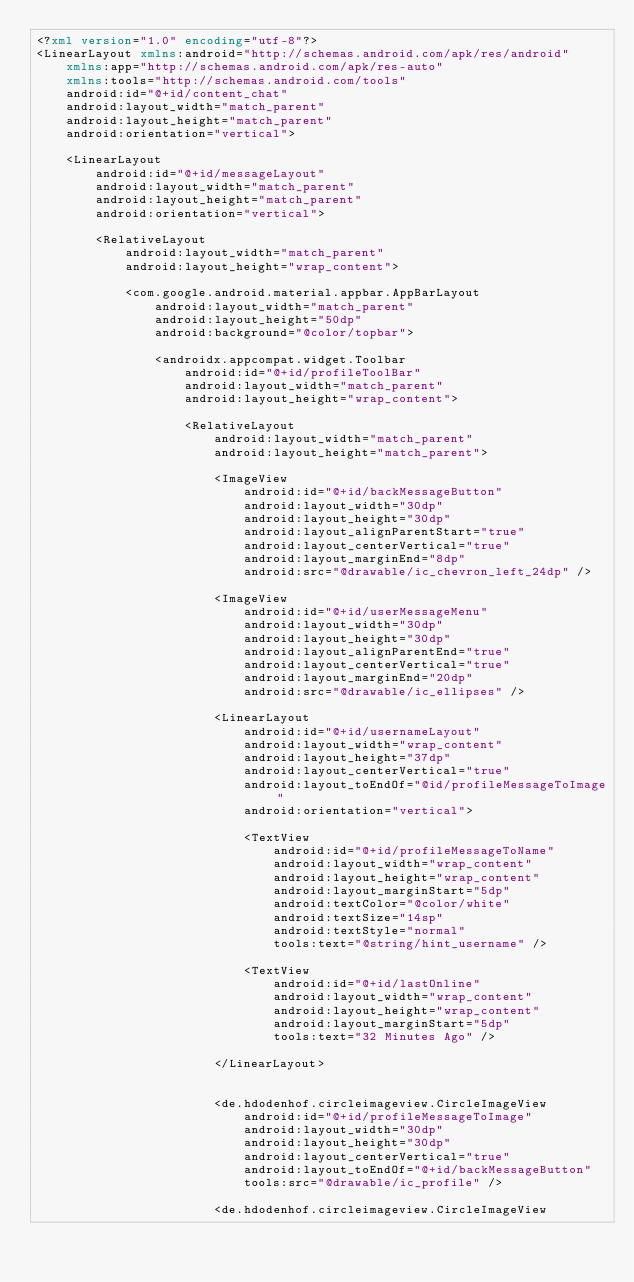<code> <loc_0><loc_0><loc_500><loc_500><_XML_><?xml version="1.0" encoding="utf-8"?>
<LinearLayout xmlns:android="http://schemas.android.com/apk/res/android"
    xmlns:app="http://schemas.android.com/apk/res-auto"
    xmlns:tools="http://schemas.android.com/tools"
    android:id="@+id/content_chat"
    android:layout_width="match_parent"
    android:layout_height="match_parent"
    android:orientation="vertical">

    <LinearLayout
        android:id="@+id/messageLayout"
        android:layout_width="match_parent"
        android:layout_height="match_parent"
        android:orientation="vertical">

        <RelativeLayout
            android:layout_width="match_parent"
            android:layout_height="wrap_content">

            <com.google.android.material.appbar.AppBarLayout
                android:layout_width="match_parent"
                android:layout_height="50dp"
                android:background="@color/topbar">

                <androidx.appcompat.widget.Toolbar
                    android:id="@+id/profileToolBar"
                    android:layout_width="match_parent"
                    android:layout_height="wrap_content">

                    <RelativeLayout
                        android:layout_width="match_parent"
                        android:layout_height="match_parent">

                        <ImageView
                            android:id="@+id/backMessageButton"
                            android:layout_width="30dp"
                            android:layout_height="30dp"
                            android:layout_alignParentStart="true"
                            android:layout_centerVertical="true"
                            android:layout_marginEnd="8dp"
                            android:src="@drawable/ic_chevron_left_24dp" />

                        <ImageView
                            android:id="@+id/userMessageMenu"
                            android:layout_width="30dp"
                            android:layout_height="30dp"
                            android:layout_alignParentEnd="true"
                            android:layout_centerVertical="true"
                            android:layout_marginEnd="20dp"
                            android:src="@drawable/ic_ellipses" />

                        <LinearLayout
                            android:id="@+id/usernameLayout"
                            android:layout_width="wrap_content"
                            android:layout_height="37dp"
                            android:layout_centerVertical="true"
                            android:layout_toEndOf="@id/profileMessageToImage"
                            android:orientation="vertical">

                            <TextView
                                android:id="@+id/profileMessageToName"
                                android:layout_width="wrap_content"
                                android:layout_height="wrap_content"
                                android:layout_marginStart="5dp"
                                android:textColor="@color/white"
                                android:textSize="14sp"
                                android:textStyle="normal"
                                tools:text="@string/hint_username" />

                            <TextView
                                android:id="@+id/lastOnline"
                                android:layout_width="wrap_content"
                                android:layout_height="wrap_content"
                                android:layout_marginStart="5dp"
                                tools:text="32 Minutes Ago" />

                        </LinearLayout>


                        <de.hdodenhof.circleimageview.CircleImageView
                            android:id="@+id/profileMessageToImage"
                            android:layout_width="30dp"
                            android:layout_height="30dp"
                            android:layout_centerVertical="true"
                            android:layout_toEndOf="@+id/backMessageButton"
                            tools:src="@drawable/ic_profile" />

                        <de.hdodenhof.circleimageview.CircleImageView</code> 